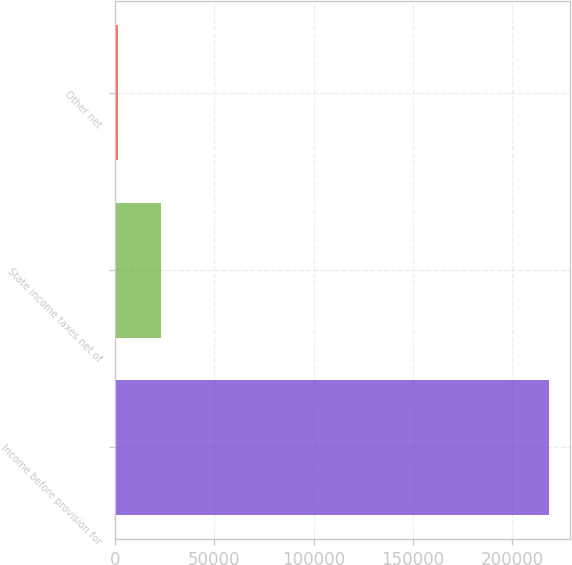Convert chart. <chart><loc_0><loc_0><loc_500><loc_500><bar_chart><fcel>Income before provision for<fcel>State income taxes net of<fcel>Other net<nl><fcel>218426<fcel>23357.3<fcel>1683<nl></chart> 